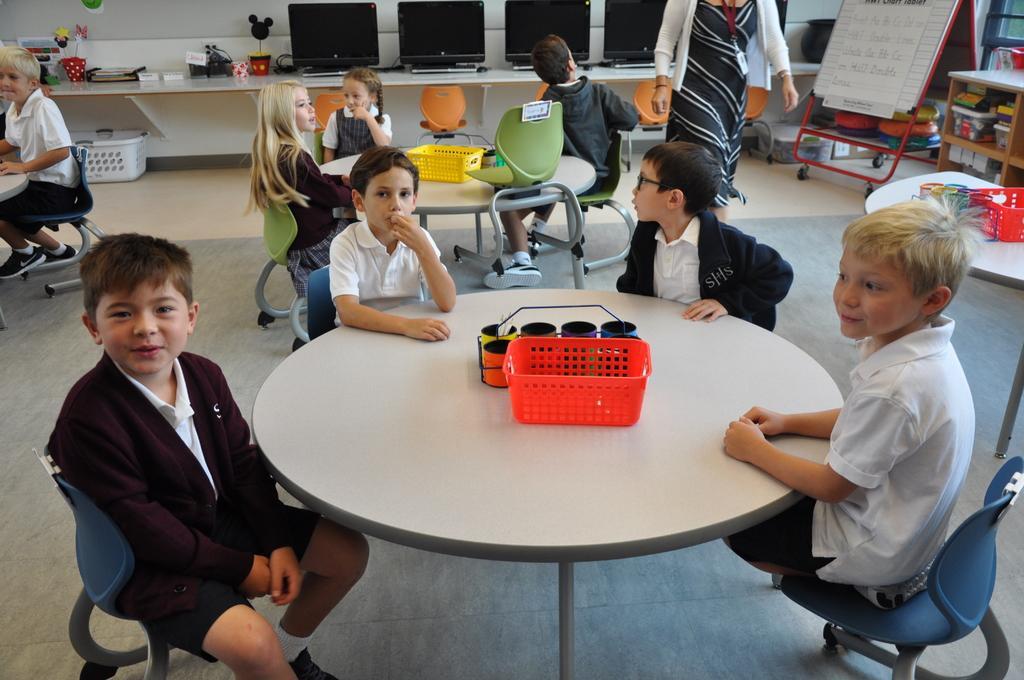Please provide a concise description of this image. This picture describes about group of children seated on the chair and woman is standing, in front of the children we can see basket and some cups on the table, and also we can see flower vase, monitors in the image. 